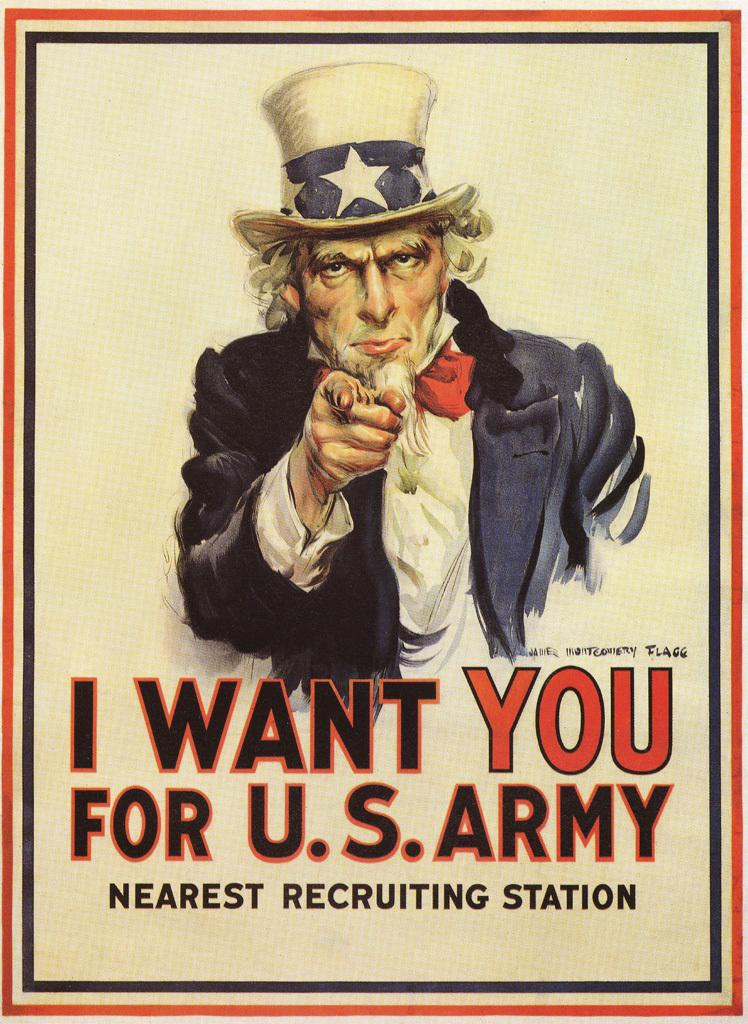<image>
Summarize the visual content of the image. I want you for U.S Army nearest recruiting station poster 